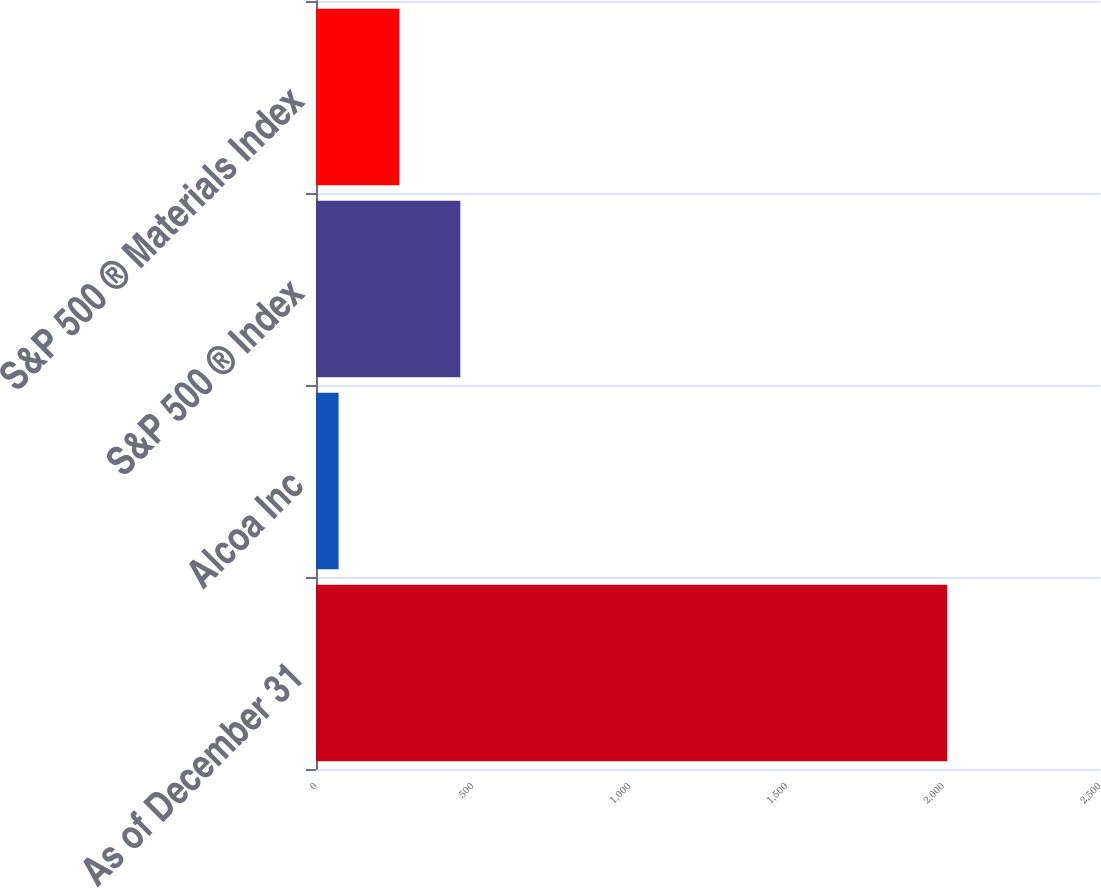Convert chart to OTSL. <chart><loc_0><loc_0><loc_500><loc_500><bar_chart><fcel>As of December 31<fcel>Alcoa Inc<fcel>S&P 500 ® Index<fcel>S&P 500 ® Materials Index<nl><fcel>2013<fcel>72<fcel>460.2<fcel>266.1<nl></chart> 